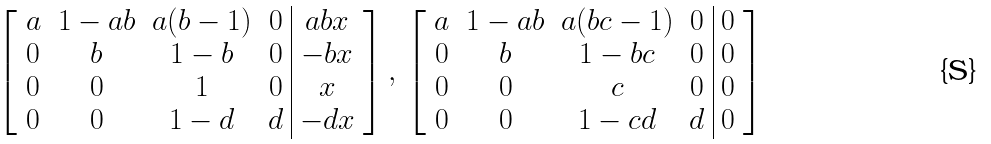Convert formula to latex. <formula><loc_0><loc_0><loc_500><loc_500>\left [ \begin{array} { c c c c | c } a & 1 - a b & a ( b - 1 ) & 0 & a b x \\ 0 & b & 1 - b & 0 & - b x \\ 0 & 0 & 1 & 0 & x \\ 0 & 0 & 1 - d & d & - d x \end{array} \right ] , \, \left [ \begin{array} { c c c c | c } a & 1 - a b & a ( b c - 1 ) & 0 & 0 \\ 0 & b & 1 - b c & 0 & 0 \\ 0 & 0 & c & 0 & 0 \\ 0 & 0 & 1 - c d & d & 0 \end{array} \right ]</formula> 